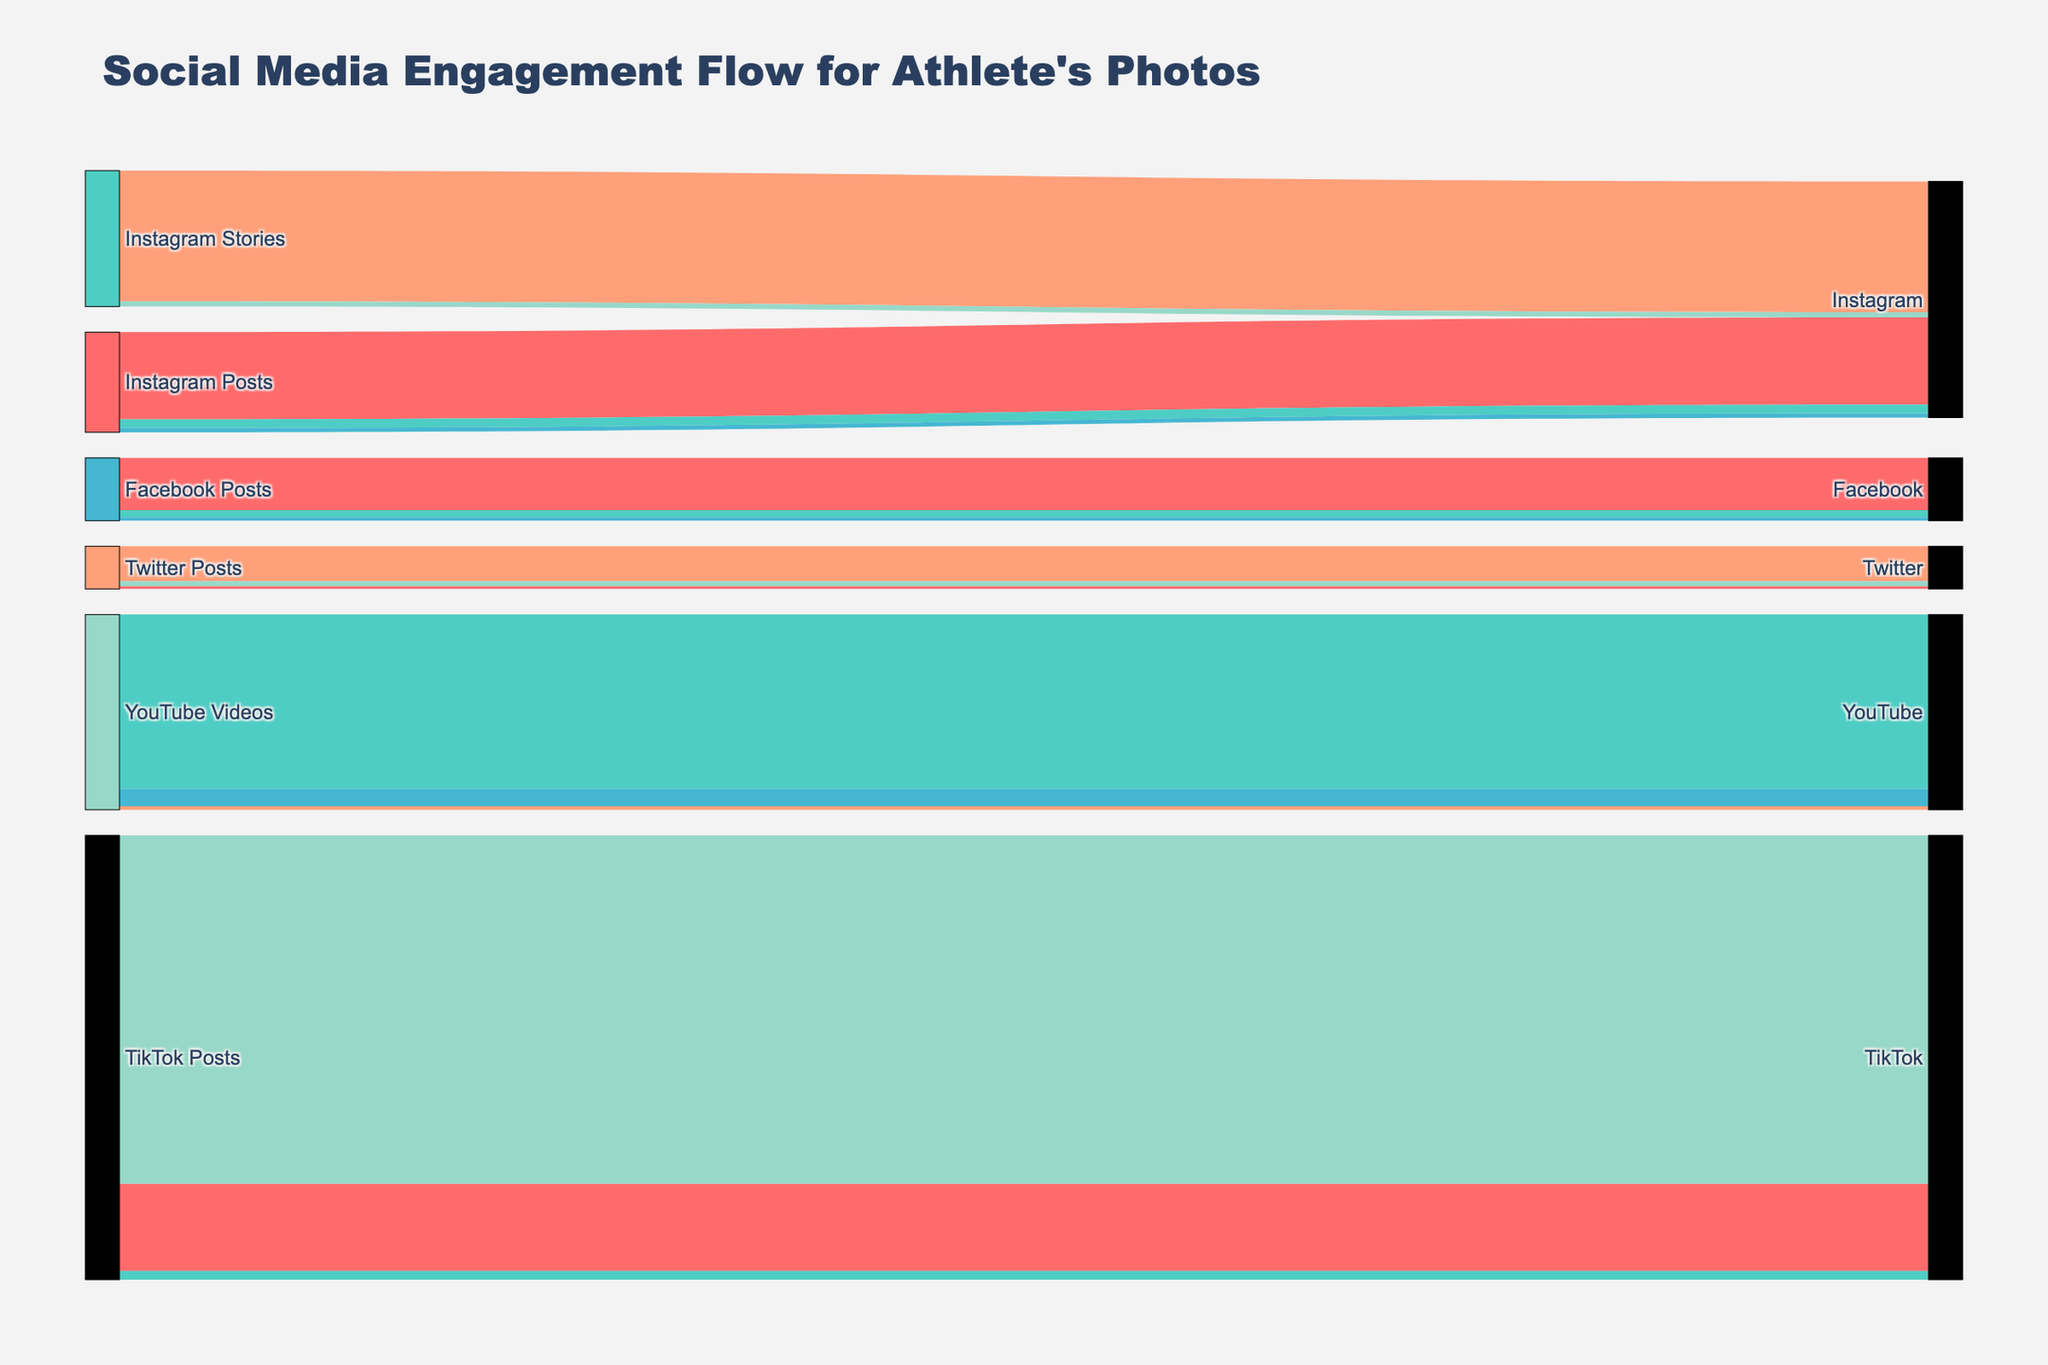What platforms are highlighted in the diagram? The platforms are represented as target nodes and include Instagram, Facebook, Twitter, YouTube, and TikTok.
Answer: Instagram, Facebook, Twitter, YouTube, TikTok How many different sources of content are shown in the diagram? By observing the labeled nodes at the beginning, you can see there are four distinct sources of content: Instagram Posts, Instagram Stories, Facebook Posts, Twitter Posts, YouTube Videos, and TikTok Posts.
Answer: 6 Which engagement type has the highest count on Instagram Posts? Referring to the engagement types for Instagram Posts, Likes have the highest count with 500,000.
Answer: Likes What's the total engagement count from Instagram (Posts and Stories)? Sum the counts from all engagement types in both Instagram Posts and Instagram Stories: 500,000 (Likes) + 50,000 (Comments) + 25,000 (Shares) + 750,000 (Views) + 30,000 (Replies) = 1,355,000.
Answer: 1,355,000 Compare the engagement counts of Facebook and Twitter Posts. Which one is greater? Sum the counts for all engagement types in Facebook Posts: 300,000 (Likes) + 40,000 (Comments) + 20,000 (Shares) = 360,000. Sum the counts for all engagement types in Twitter Posts: 200,000 (Likes) + 30,000 (Retweets) + 15,000 (Replies) = 245,000. Facebook has a greater engagement count.
Answer: Facebook Which content source has the most views overall? Compare the view counts: Instagram Stories have 750,000 views and YouTube Videos have 1,000,000 views. TikTok Posts have 2,000,000 views. TikTok has the most views.
Answer: TikTok Posts What is the combined count of all comments across all platforms? Sum the counts of comments from all platforms: Instagram Posts 50,000 + YouTube Videos 20,000 + TikTok Posts 50,000 + Facebook Posts 40,000 + Twitter Posts 15,000 = 175,000.
Answer: 175,000 What's the color scheme used in the diagram? The colors used in the diagram are a variety of bright, contrasting colors: red, teal, blue, peach, and light green.
Answer: Red, teal, blue, peach, light green How many engagement types are represented in the Sankey diagram? The engagement types are distinct nodes connected to Platforms. They include Likes, Comments, Shares, Views, Replies, and Retweets. There are six types in total.
Answer: 6 